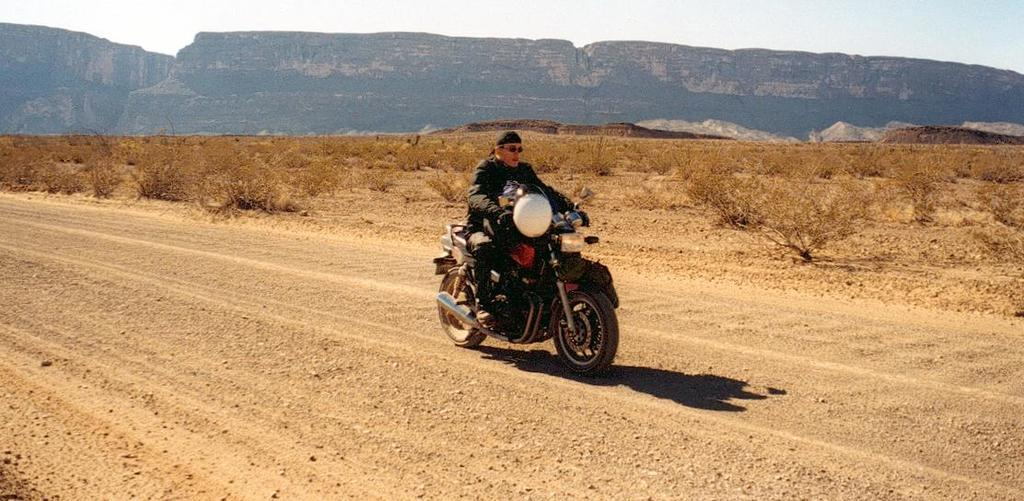Who or what is the main subject in the image? There is a person in the image. What is the person wearing? The person is wearing a black dress. What activity is the person engaged in? The person is riding a bike. What can be seen in the distance behind the person? There are mountains visible in the background. What type of terrain is the person riding on? The ground appears to have sand. Where is the church located in the image? There is no church present in the image. What type of beast is accompanying the person on the bike? There is no beast present in the image; the person is riding the bike alone. 